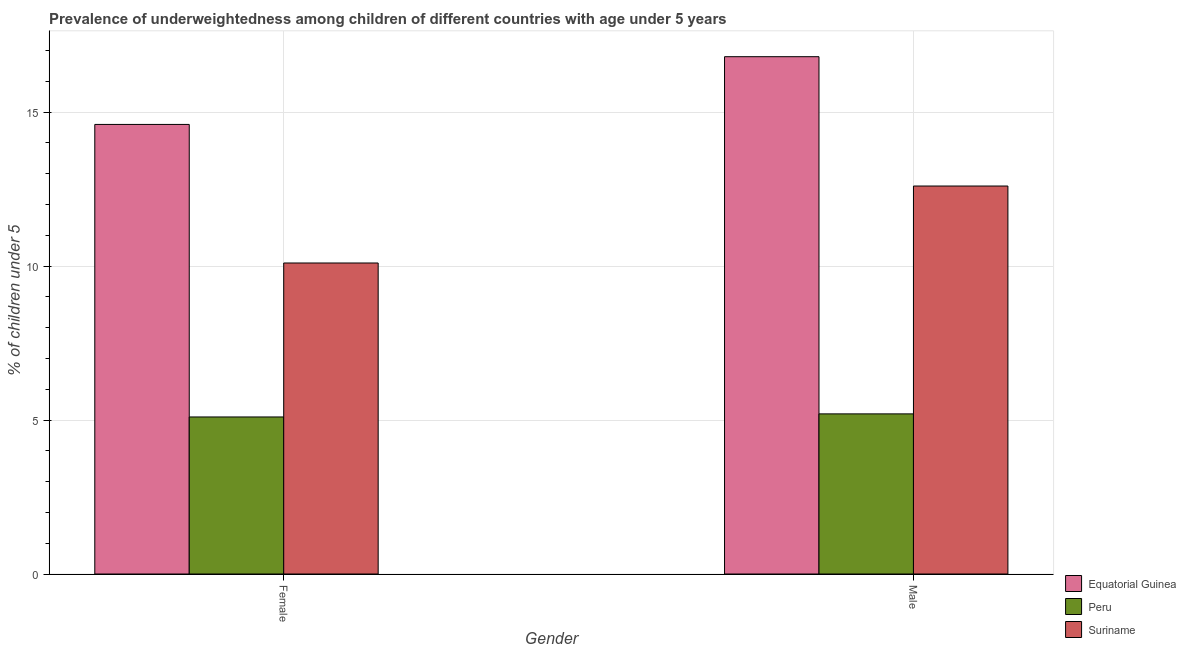How many different coloured bars are there?
Offer a very short reply. 3. How many groups of bars are there?
Offer a very short reply. 2. Are the number of bars per tick equal to the number of legend labels?
Keep it short and to the point. Yes. Are the number of bars on each tick of the X-axis equal?
Your answer should be very brief. Yes. How many bars are there on the 1st tick from the right?
Your answer should be compact. 3. What is the percentage of underweighted male children in Equatorial Guinea?
Your response must be concise. 16.8. Across all countries, what is the maximum percentage of underweighted female children?
Your answer should be compact. 14.6. Across all countries, what is the minimum percentage of underweighted female children?
Give a very brief answer. 5.1. In which country was the percentage of underweighted female children maximum?
Ensure brevity in your answer.  Equatorial Guinea. In which country was the percentage of underweighted male children minimum?
Your answer should be compact. Peru. What is the total percentage of underweighted male children in the graph?
Provide a succinct answer. 34.6. What is the difference between the percentage of underweighted male children in Peru and that in Suriname?
Provide a short and direct response. -7.4. What is the difference between the percentage of underweighted male children in Suriname and the percentage of underweighted female children in Peru?
Make the answer very short. 7.5. What is the average percentage of underweighted female children per country?
Keep it short and to the point. 9.93. What is the difference between the percentage of underweighted female children and percentage of underweighted male children in Equatorial Guinea?
Your response must be concise. -2.2. What is the ratio of the percentage of underweighted male children in Peru to that in Equatorial Guinea?
Offer a very short reply. 0.31. Is the percentage of underweighted male children in Peru less than that in Suriname?
Offer a very short reply. Yes. What does the 3rd bar from the left in Female represents?
Your answer should be very brief. Suriname. What does the 1st bar from the right in Male represents?
Give a very brief answer. Suriname. How many bars are there?
Provide a succinct answer. 6. Are the values on the major ticks of Y-axis written in scientific E-notation?
Offer a very short reply. No. Does the graph contain any zero values?
Make the answer very short. No. Does the graph contain grids?
Offer a terse response. Yes. How many legend labels are there?
Your answer should be very brief. 3. What is the title of the graph?
Keep it short and to the point. Prevalence of underweightedness among children of different countries with age under 5 years. Does "Palau" appear as one of the legend labels in the graph?
Ensure brevity in your answer.  No. What is the label or title of the Y-axis?
Offer a terse response.  % of children under 5. What is the  % of children under 5 of Equatorial Guinea in Female?
Provide a short and direct response. 14.6. What is the  % of children under 5 of Peru in Female?
Offer a terse response. 5.1. What is the  % of children under 5 of Suriname in Female?
Ensure brevity in your answer.  10.1. What is the  % of children under 5 of Equatorial Guinea in Male?
Provide a short and direct response. 16.8. What is the  % of children under 5 in Peru in Male?
Keep it short and to the point. 5.2. What is the  % of children under 5 of Suriname in Male?
Provide a short and direct response. 12.6. Across all Gender, what is the maximum  % of children under 5 of Equatorial Guinea?
Offer a very short reply. 16.8. Across all Gender, what is the maximum  % of children under 5 of Peru?
Your answer should be compact. 5.2. Across all Gender, what is the maximum  % of children under 5 in Suriname?
Your answer should be compact. 12.6. Across all Gender, what is the minimum  % of children under 5 of Equatorial Guinea?
Keep it short and to the point. 14.6. Across all Gender, what is the minimum  % of children under 5 of Peru?
Provide a succinct answer. 5.1. Across all Gender, what is the minimum  % of children under 5 of Suriname?
Ensure brevity in your answer.  10.1. What is the total  % of children under 5 in Equatorial Guinea in the graph?
Offer a terse response. 31.4. What is the total  % of children under 5 of Peru in the graph?
Keep it short and to the point. 10.3. What is the total  % of children under 5 in Suriname in the graph?
Your answer should be compact. 22.7. What is the difference between the  % of children under 5 in Equatorial Guinea in Female and that in Male?
Give a very brief answer. -2.2. What is the difference between the  % of children under 5 in Equatorial Guinea in Female and the  % of children under 5 in Peru in Male?
Give a very brief answer. 9.4. What is the difference between the  % of children under 5 in Equatorial Guinea in Female and the  % of children under 5 in Suriname in Male?
Provide a succinct answer. 2. What is the average  % of children under 5 of Peru per Gender?
Offer a very short reply. 5.15. What is the average  % of children under 5 of Suriname per Gender?
Provide a succinct answer. 11.35. What is the difference between the  % of children under 5 in Equatorial Guinea and  % of children under 5 in Peru in Male?
Ensure brevity in your answer.  11.6. What is the difference between the  % of children under 5 in Equatorial Guinea and  % of children under 5 in Suriname in Male?
Give a very brief answer. 4.2. What is the ratio of the  % of children under 5 of Equatorial Guinea in Female to that in Male?
Keep it short and to the point. 0.87. What is the ratio of the  % of children under 5 of Peru in Female to that in Male?
Your answer should be compact. 0.98. What is the ratio of the  % of children under 5 in Suriname in Female to that in Male?
Your response must be concise. 0.8. What is the difference between the highest and the second highest  % of children under 5 in Equatorial Guinea?
Give a very brief answer. 2.2. What is the difference between the highest and the second highest  % of children under 5 of Suriname?
Offer a very short reply. 2.5. What is the difference between the highest and the lowest  % of children under 5 of Equatorial Guinea?
Give a very brief answer. 2.2. What is the difference between the highest and the lowest  % of children under 5 of Suriname?
Ensure brevity in your answer.  2.5. 